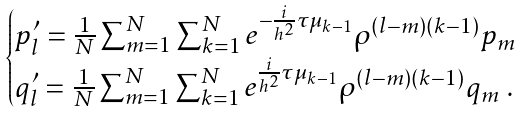Convert formula to latex. <formula><loc_0><loc_0><loc_500><loc_500>\begin{cases} p _ { l } ^ { \prime } = \frac { 1 } { N } \sum _ { m = 1 } ^ { N } \sum _ { k = 1 } ^ { N } e ^ { - \frac { i } { h ^ { 2 } } \tau \mu _ { k - 1 } } \rho ^ { ( l - m ) ( k - 1 ) } p _ { m } \\ q _ { l } ^ { \prime } = \frac { 1 } { N } \sum _ { m = 1 } ^ { N } \sum _ { k = 1 } ^ { N } e ^ { \frac { i } { h ^ { 2 } } \tau \mu _ { k - 1 } } \rho ^ { ( l - m ) ( k - 1 ) } q _ { m } \ . \end{cases}</formula> 